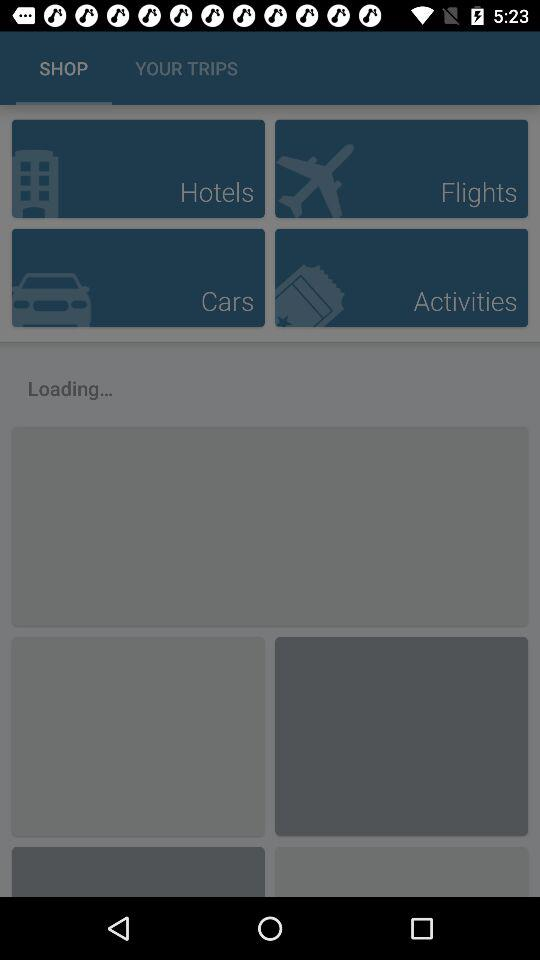How much is the hotel room per night?
When the provided information is insufficient, respond with <no answer>. <no answer> 